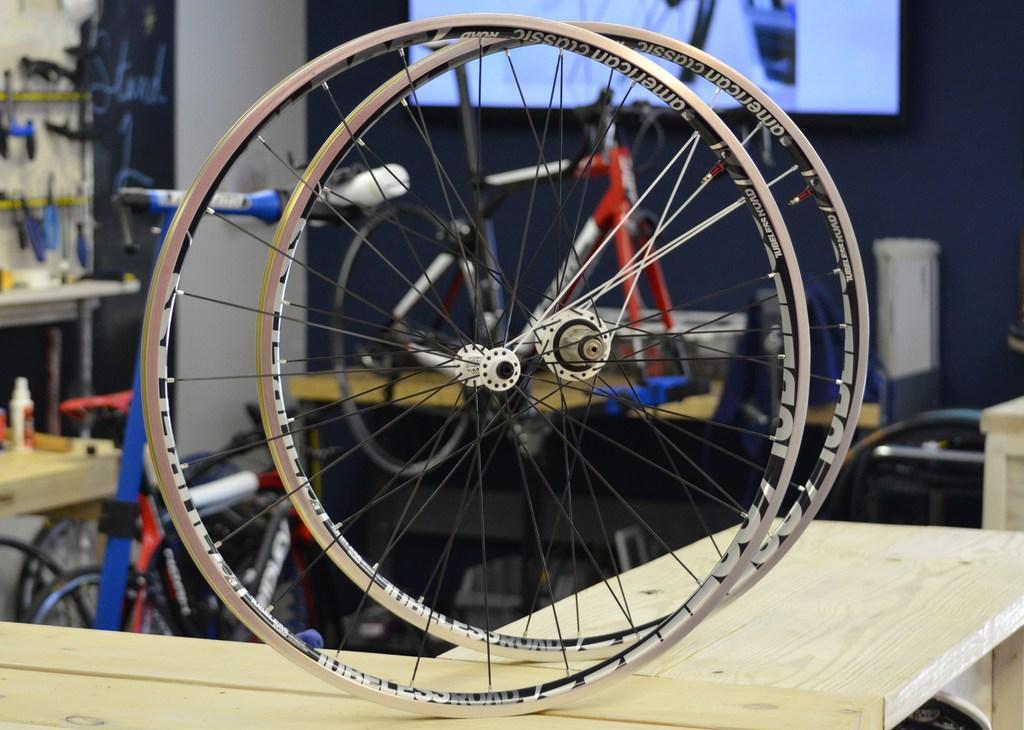In one or two sentences, can you explain what this image depicts? In this image we can see the bicycle wheels on the wooden table. In the background we can see the bicycles, a bottle on the wooden table and some other objects. We can also see the wall and also the screen. 